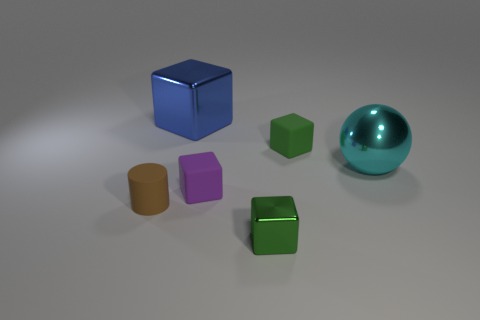The tiny thing that is to the left of the small green metal block and right of the brown matte cylinder is made of what material?
Ensure brevity in your answer.  Rubber. How many big blue things have the same shape as the green matte thing?
Provide a succinct answer. 1. What size is the green object on the left side of the green object that is behind the cyan shiny object?
Your answer should be very brief. Small. There is a cube in front of the tiny purple object; is it the same color as the metal cube that is behind the rubber cylinder?
Provide a succinct answer. No. There is a tiny rubber object right of the metal cube that is in front of the matte cylinder; how many shiny things are to the right of it?
Your answer should be very brief. 1. How many blocks are in front of the big blue object and behind the purple matte block?
Keep it short and to the point. 1. Is the number of green rubber objects that are in front of the cyan sphere greater than the number of big metal objects?
Your response must be concise. No. What number of cyan metal balls are the same size as the green metal object?
Offer a very short reply. 0. There is a rubber thing that is the same color as the tiny metal block; what size is it?
Provide a succinct answer. Small. How many small objects are blocks or rubber objects?
Make the answer very short. 4. 